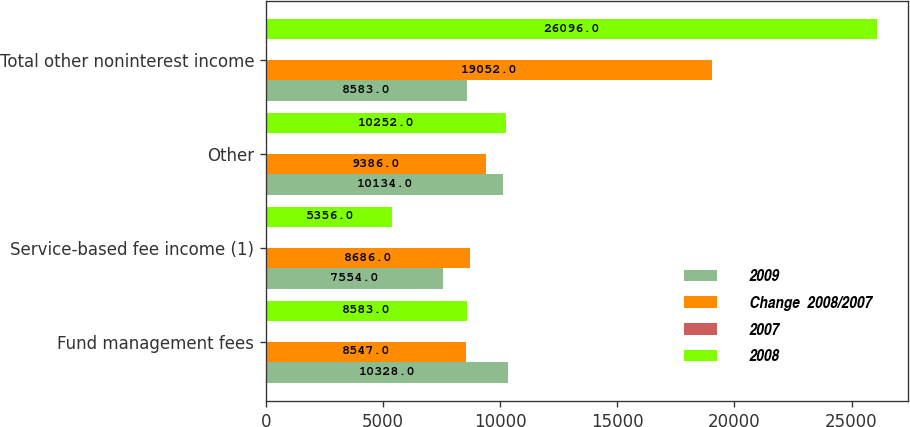<chart> <loc_0><loc_0><loc_500><loc_500><stacked_bar_chart><ecel><fcel>Fund management fees<fcel>Service-based fee income (1)<fcel>Other<fcel>Total other noninterest income<nl><fcel>2009<fcel>10328<fcel>7554<fcel>10134<fcel>8583<nl><fcel>Change  2008/2007<fcel>8547<fcel>8686<fcel>9386<fcel>19052<nl><fcel>2007<fcel>20.8<fcel>13<fcel>8<fcel>57.3<nl><fcel>2008<fcel>8583<fcel>5356<fcel>10252<fcel>26096<nl></chart> 